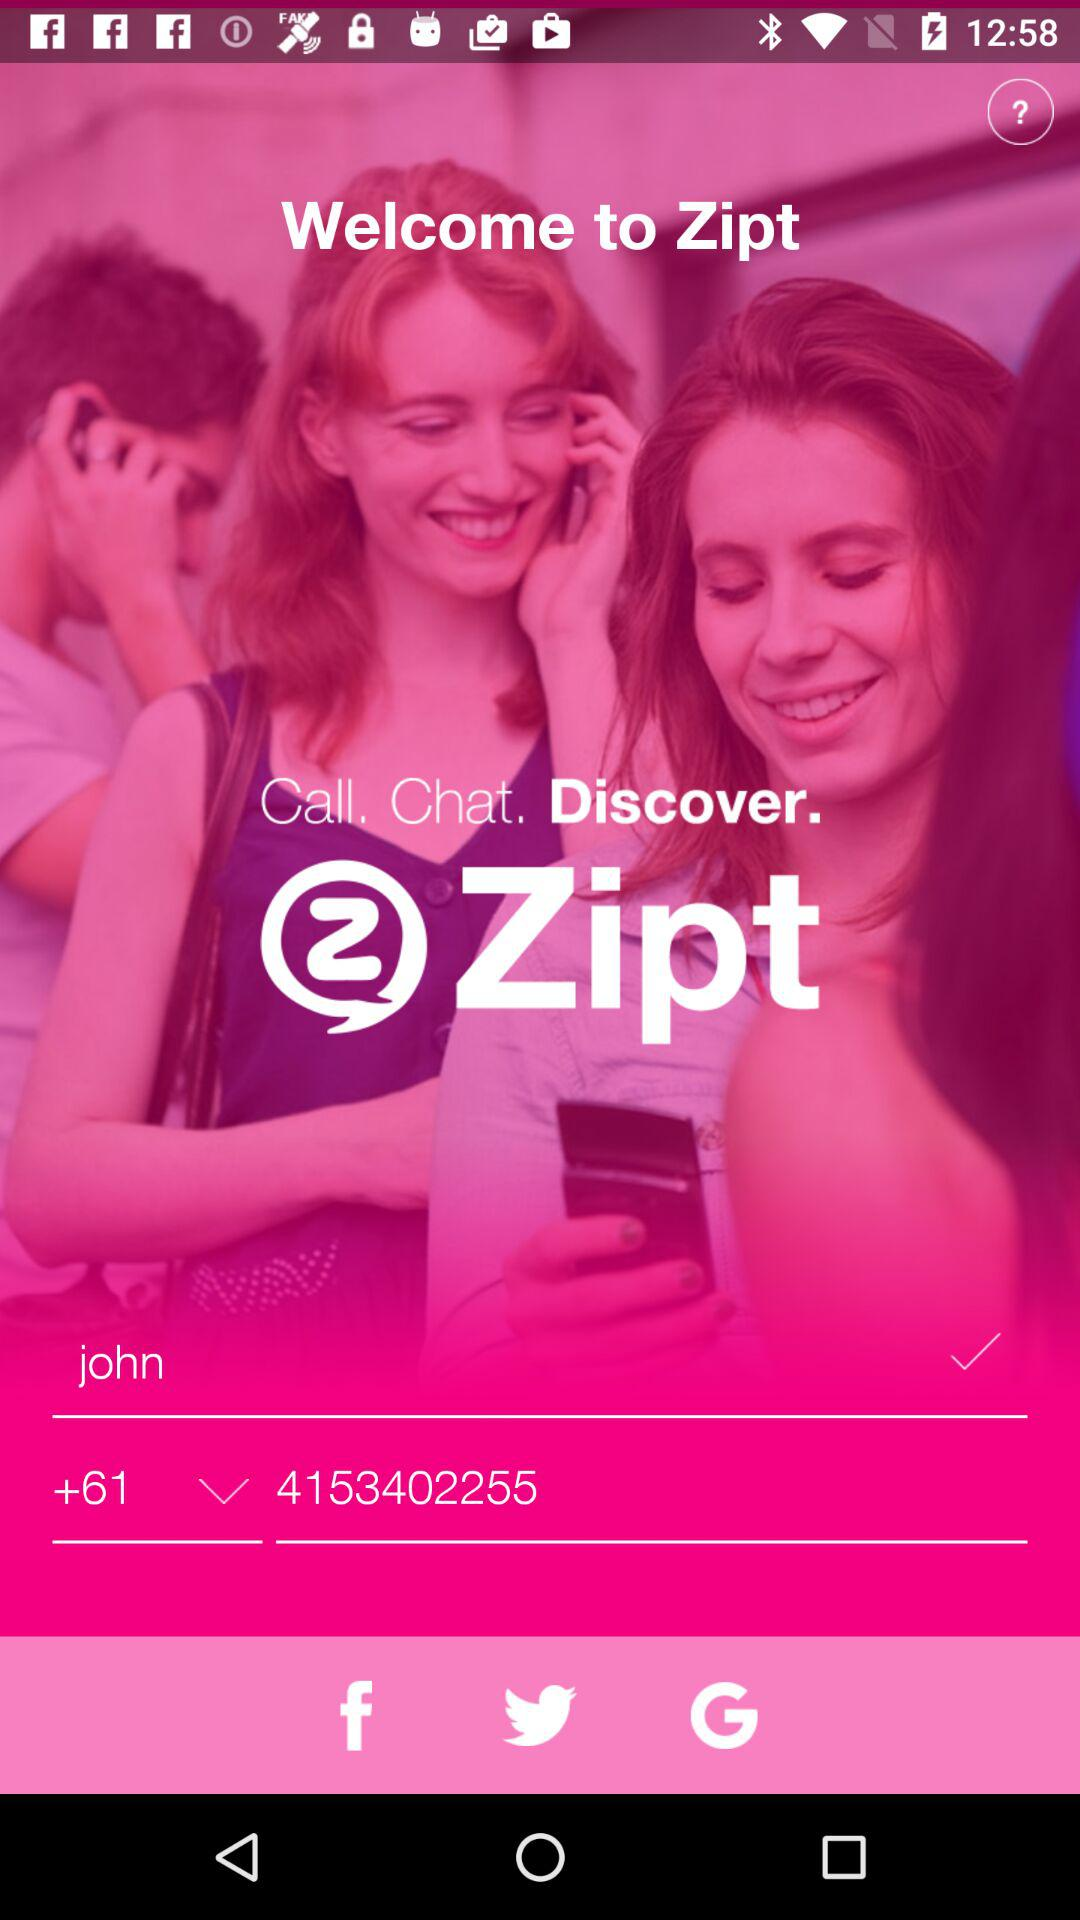How many text inputs are there that are not empty?
Answer the question using a single word or phrase. 2 